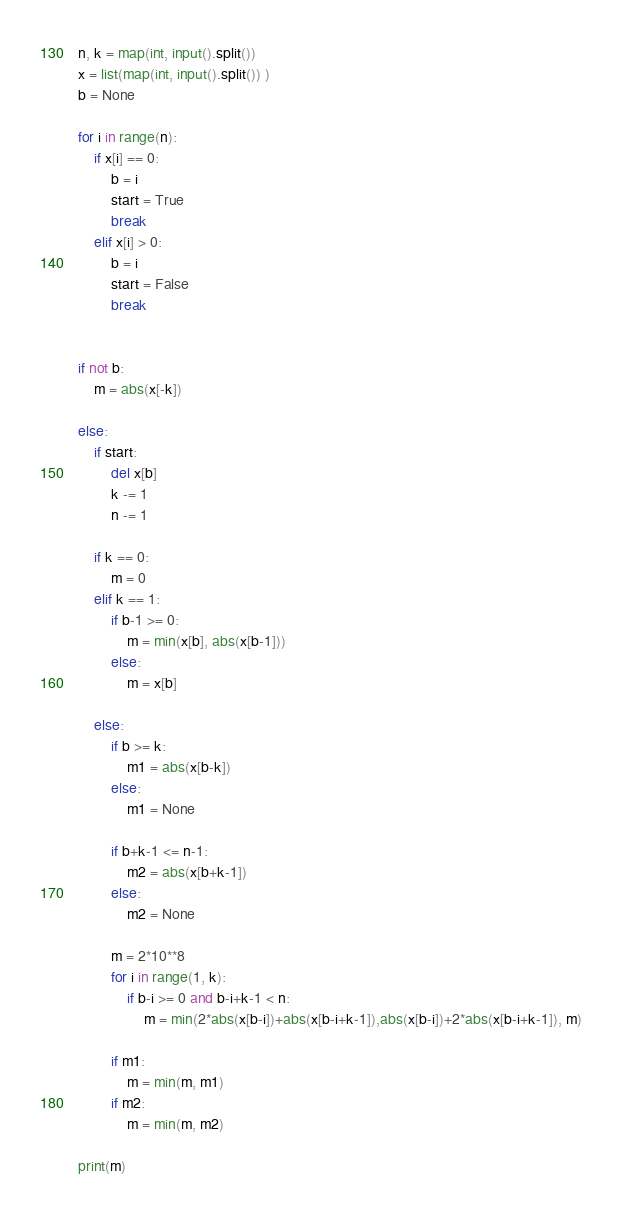Convert code to text. <code><loc_0><loc_0><loc_500><loc_500><_Python_>n, k = map(int, input().split())
x = list(map(int, input().split()) )
b = None

for i in range(n):
    if x[i] == 0:
        b = i
        start = True
        break
    elif x[i] > 0:
        b = i
        start = False
        break


if not b:
    m = abs(x[-k])

else:
    if start:
        del x[b]
        k -= 1
        n -= 1

    if k == 0:
        m = 0
    elif k == 1:
        if b-1 >= 0:
            m = min(x[b], abs(x[b-1]))
        else:
            m = x[b]

    else:
        if b >= k:
            m1 = abs(x[b-k])
        else:
            m1 = None

        if b+k-1 <= n-1:
            m2 = abs(x[b+k-1])
        else:
            m2 = None

        m = 2*10**8
        for i in range(1, k):
            if b-i >= 0 and b-i+k-1 < n:
                m = min(2*abs(x[b-i])+abs(x[b-i+k-1]),abs(x[b-i])+2*abs(x[b-i+k-1]), m)

        if m1:
            m = min(m, m1)
        if m2:
            m = min(m, m2)

print(m)

</code> 